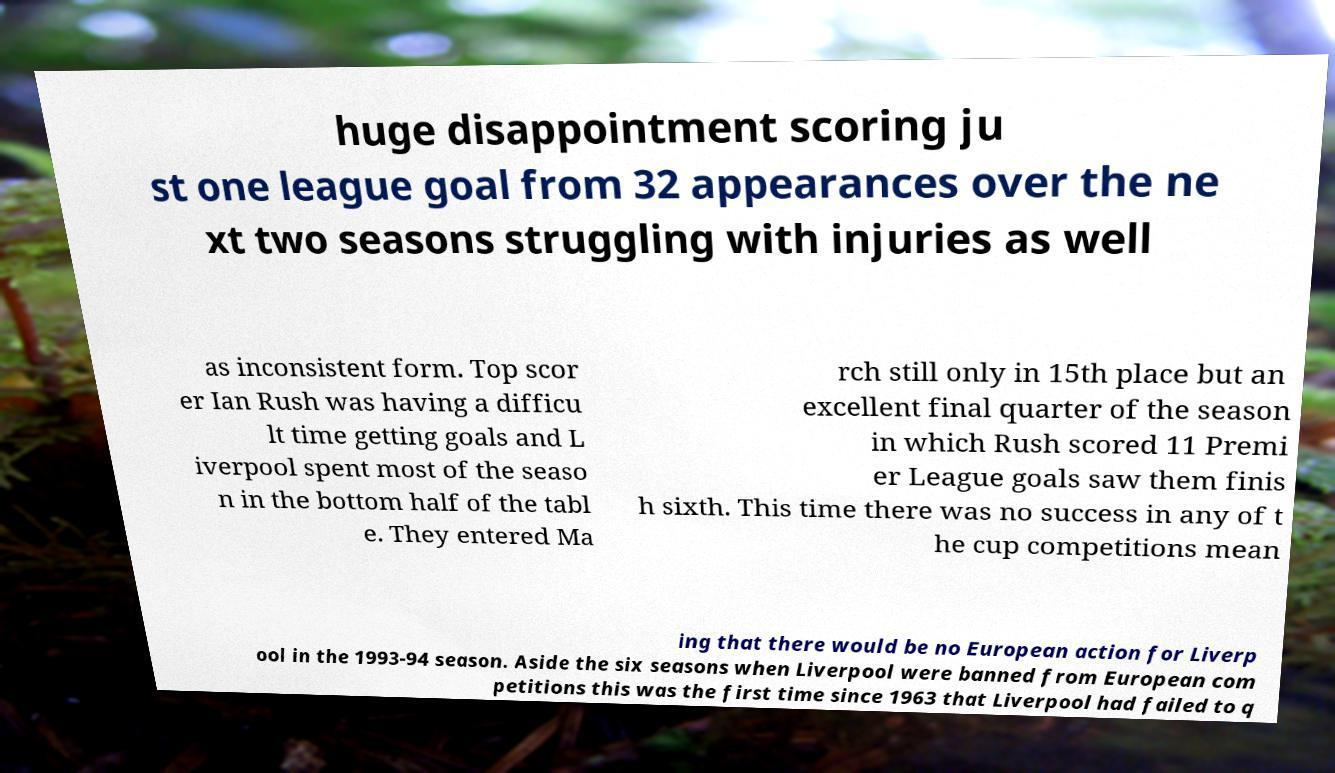Can you read and provide the text displayed in the image?This photo seems to have some interesting text. Can you extract and type it out for me? huge disappointment scoring ju st one league goal from 32 appearances over the ne xt two seasons struggling with injuries as well as inconsistent form. Top scor er Ian Rush was having a difficu lt time getting goals and L iverpool spent most of the seaso n in the bottom half of the tabl e. They entered Ma rch still only in 15th place but an excellent final quarter of the season in which Rush scored 11 Premi er League goals saw them finis h sixth. This time there was no success in any of t he cup competitions mean ing that there would be no European action for Liverp ool in the 1993-94 season. Aside the six seasons when Liverpool were banned from European com petitions this was the first time since 1963 that Liverpool had failed to q 